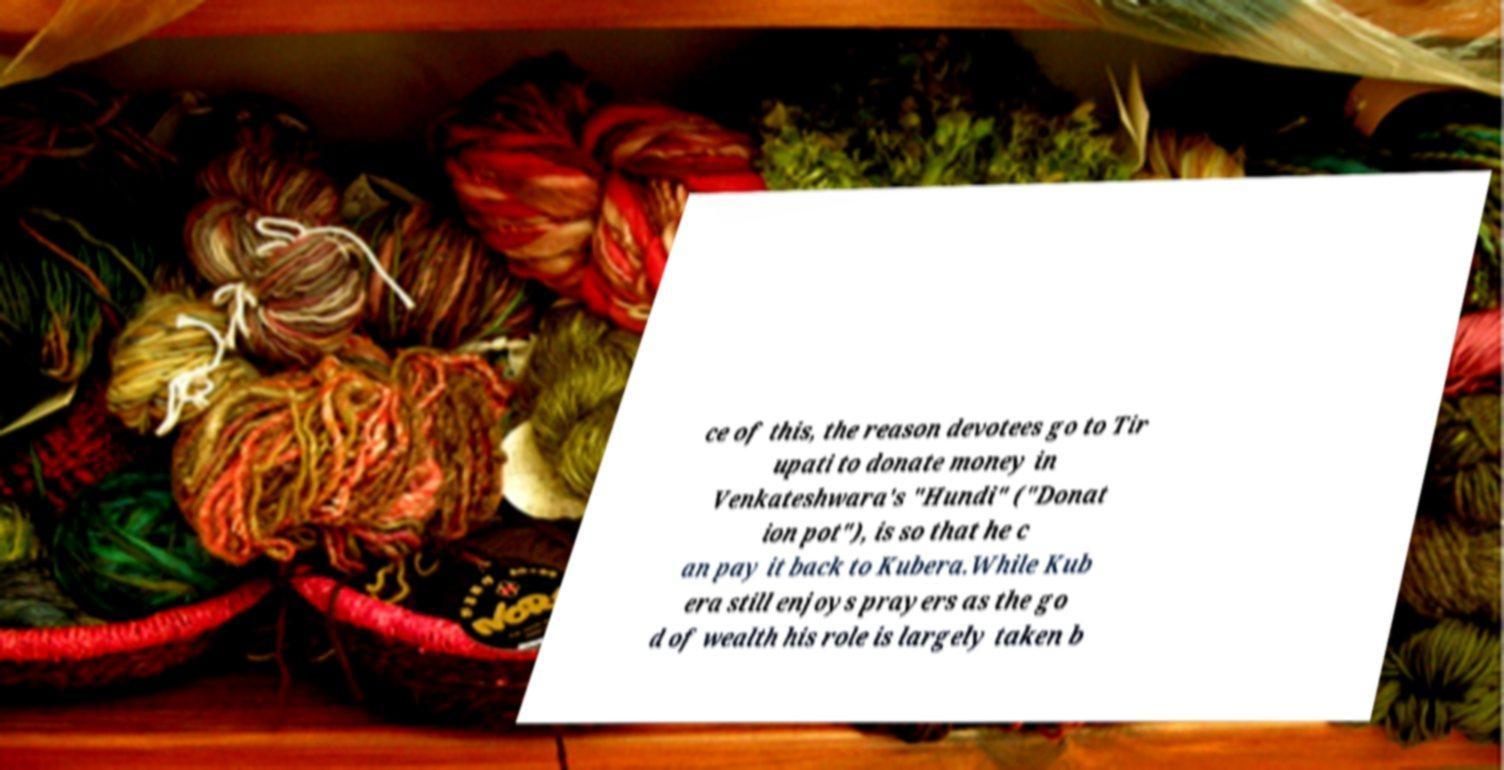What messages or text are displayed in this image? I need them in a readable, typed format. ce of this, the reason devotees go to Tir upati to donate money in Venkateshwara's "Hundi" ("Donat ion pot"), is so that he c an pay it back to Kubera.While Kub era still enjoys prayers as the go d of wealth his role is largely taken b 